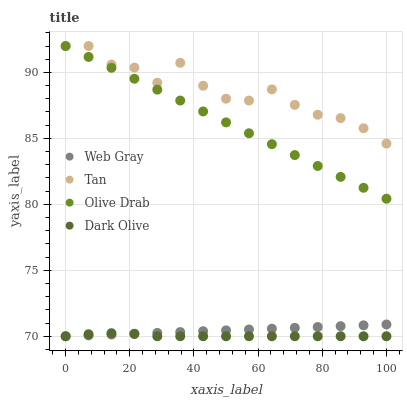Does Dark Olive have the minimum area under the curve?
Answer yes or no. Yes. Does Tan have the maximum area under the curve?
Answer yes or no. Yes. Does Web Gray have the minimum area under the curve?
Answer yes or no. No. Does Web Gray have the maximum area under the curve?
Answer yes or no. No. Is Olive Drab the smoothest?
Answer yes or no. Yes. Is Tan the roughest?
Answer yes or no. Yes. Is Web Gray the smoothest?
Answer yes or no. No. Is Web Gray the roughest?
Answer yes or no. No. Does Dark Olive have the lowest value?
Answer yes or no. Yes. Does Tan have the lowest value?
Answer yes or no. No. Does Olive Drab have the highest value?
Answer yes or no. Yes. Does Web Gray have the highest value?
Answer yes or no. No. Is Web Gray less than Olive Drab?
Answer yes or no. Yes. Is Olive Drab greater than Web Gray?
Answer yes or no. Yes. Does Dark Olive intersect Web Gray?
Answer yes or no. Yes. Is Dark Olive less than Web Gray?
Answer yes or no. No. Is Dark Olive greater than Web Gray?
Answer yes or no. No. Does Web Gray intersect Olive Drab?
Answer yes or no. No. 